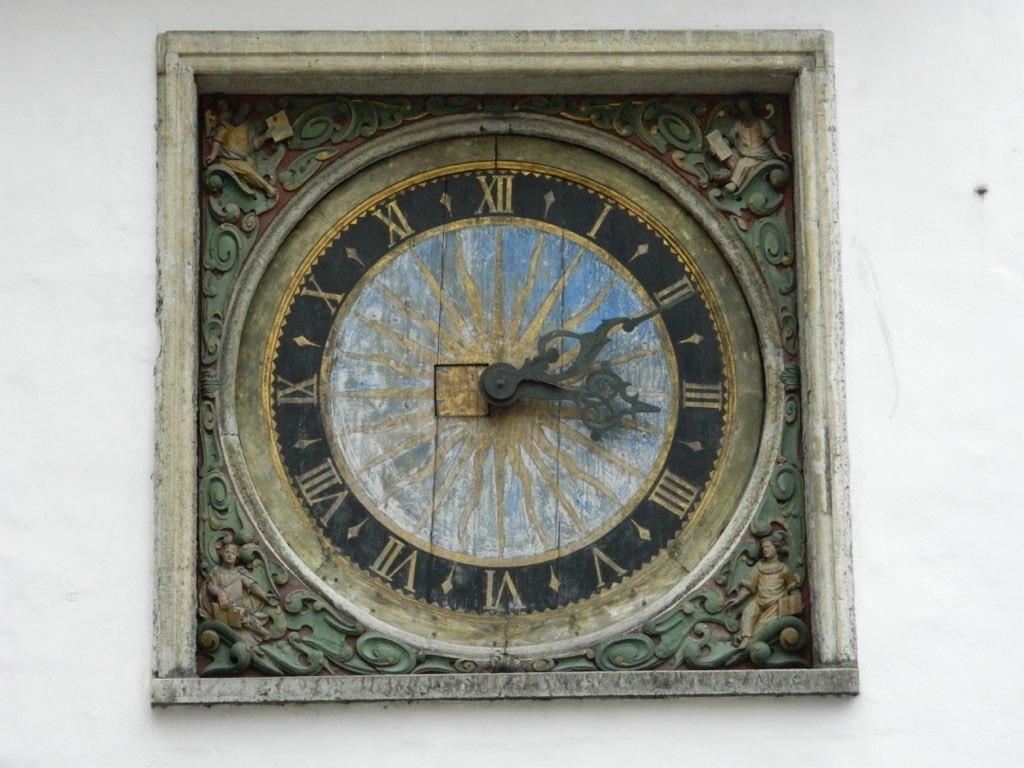What time does the clock show?
Provide a succinct answer. 3:10. 